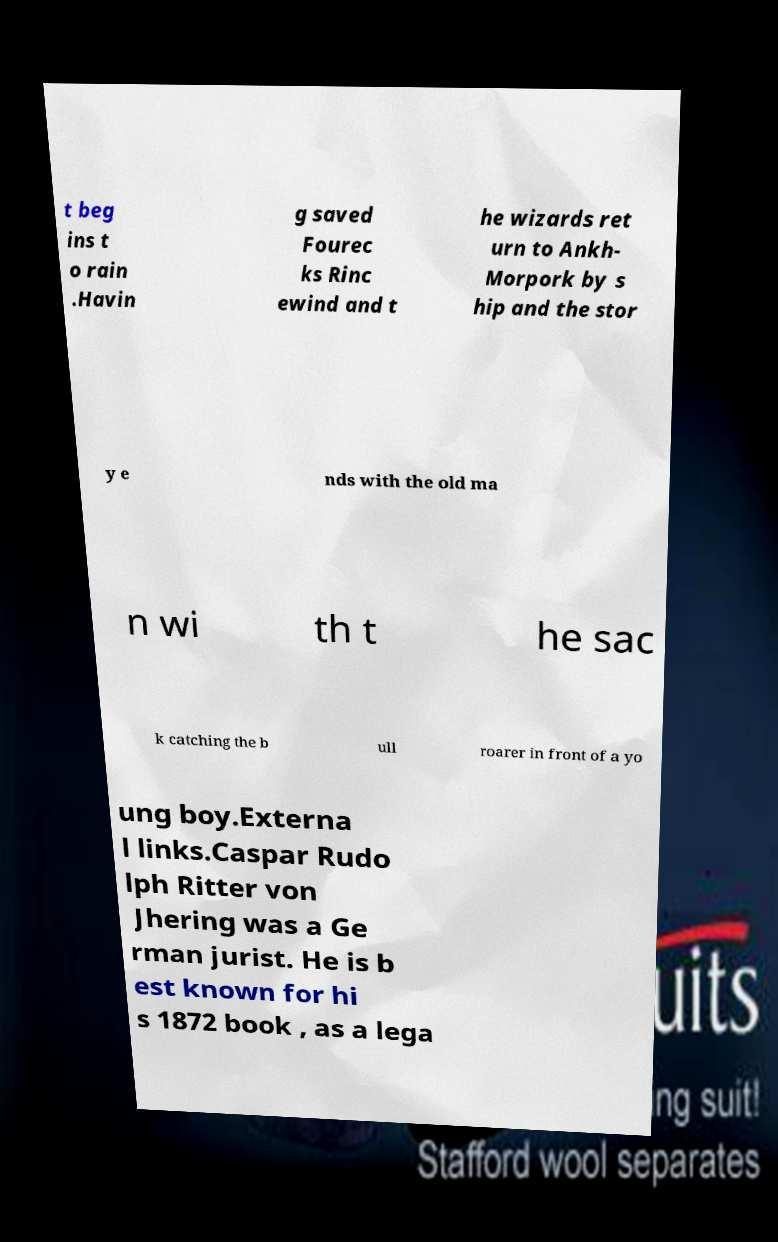Could you assist in decoding the text presented in this image and type it out clearly? t beg ins t o rain .Havin g saved Fourec ks Rinc ewind and t he wizards ret urn to Ankh- Morpork by s hip and the stor y e nds with the old ma n wi th t he sac k catching the b ull roarer in front of a yo ung boy.Externa l links.Caspar Rudo lph Ritter von Jhering was a Ge rman jurist. He is b est known for hi s 1872 book , as a lega 